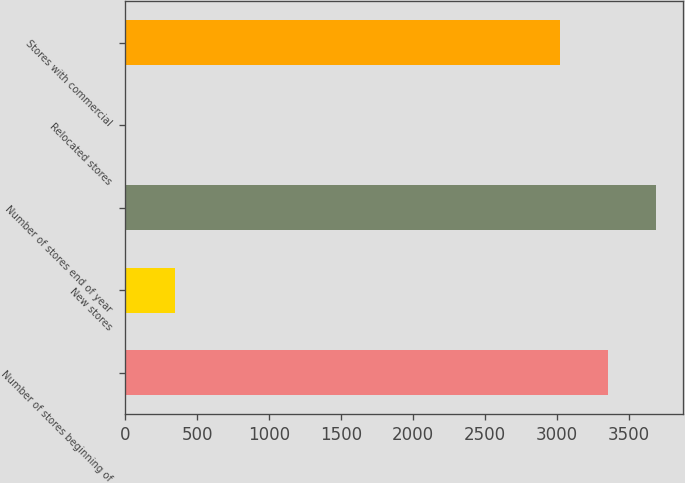<chart> <loc_0><loc_0><loc_500><loc_500><bar_chart><fcel>Number of stores beginning of<fcel>New stores<fcel>Number of stores end of year<fcel>Relocated stores<fcel>Stores with commercial<nl><fcel>3354<fcel>345<fcel>3690<fcel>9<fcel>3018<nl></chart> 